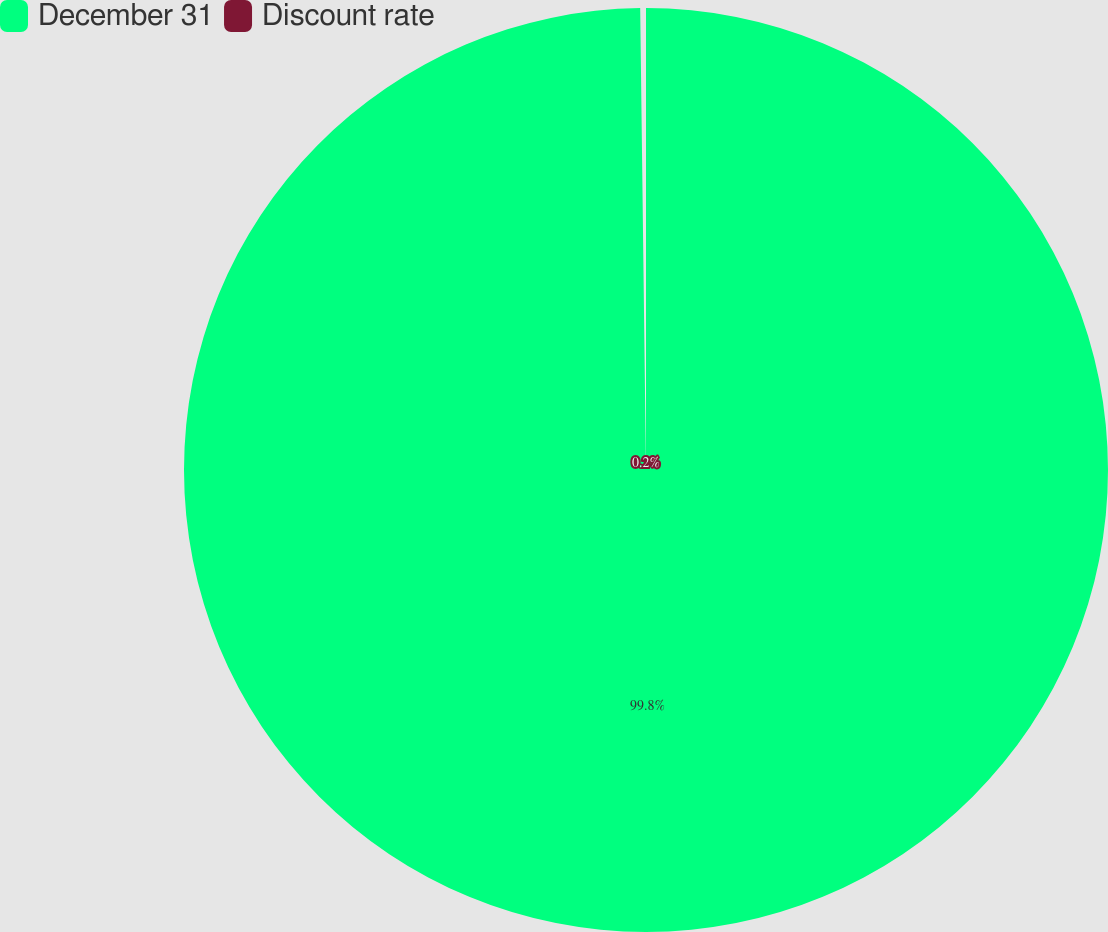<chart> <loc_0><loc_0><loc_500><loc_500><pie_chart><fcel>December 31<fcel>Discount rate<nl><fcel>99.8%<fcel>0.2%<nl></chart> 